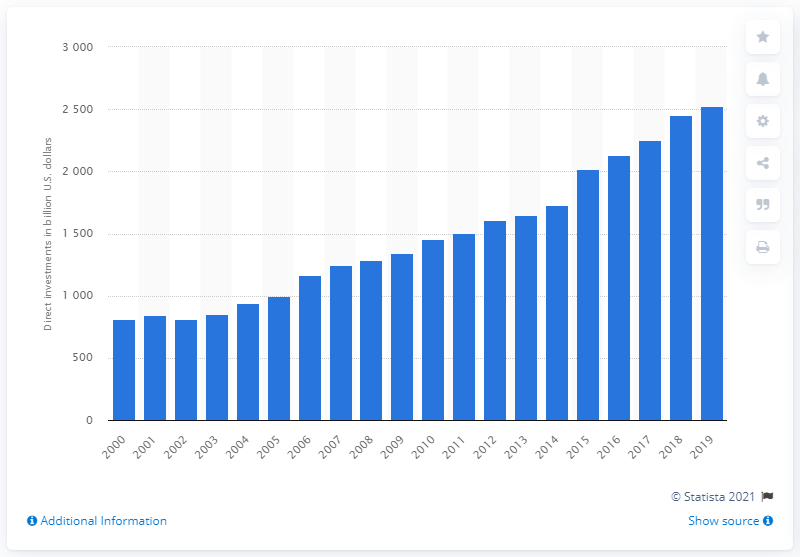List a handful of essential elements in this visual. In 2019, the European Union invested a total of 2525.15 in the United States. 